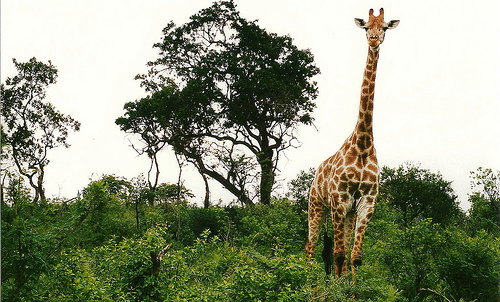<image>
Is there a giraffe next to the tree? No. The giraffe is not positioned next to the tree. They are located in different areas of the scene. 